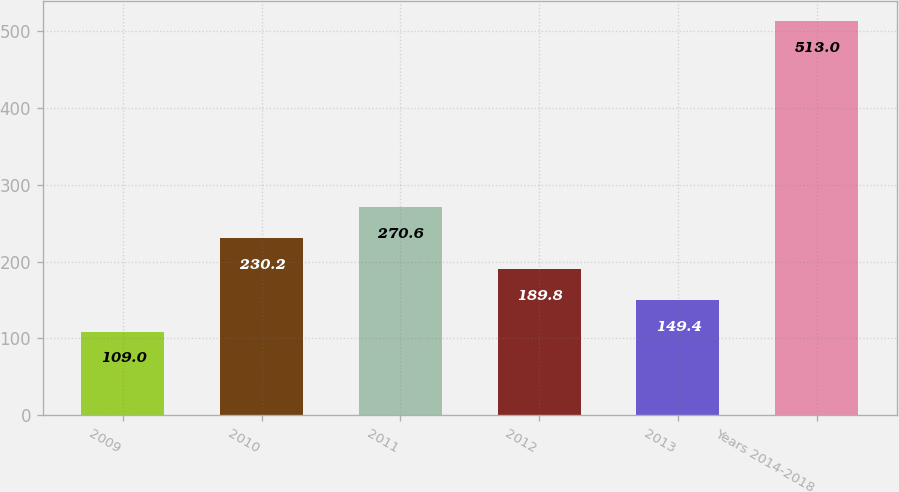Convert chart to OTSL. <chart><loc_0><loc_0><loc_500><loc_500><bar_chart><fcel>2009<fcel>2010<fcel>2011<fcel>2012<fcel>2013<fcel>Years 2014-2018<nl><fcel>109<fcel>230.2<fcel>270.6<fcel>189.8<fcel>149.4<fcel>513<nl></chart> 